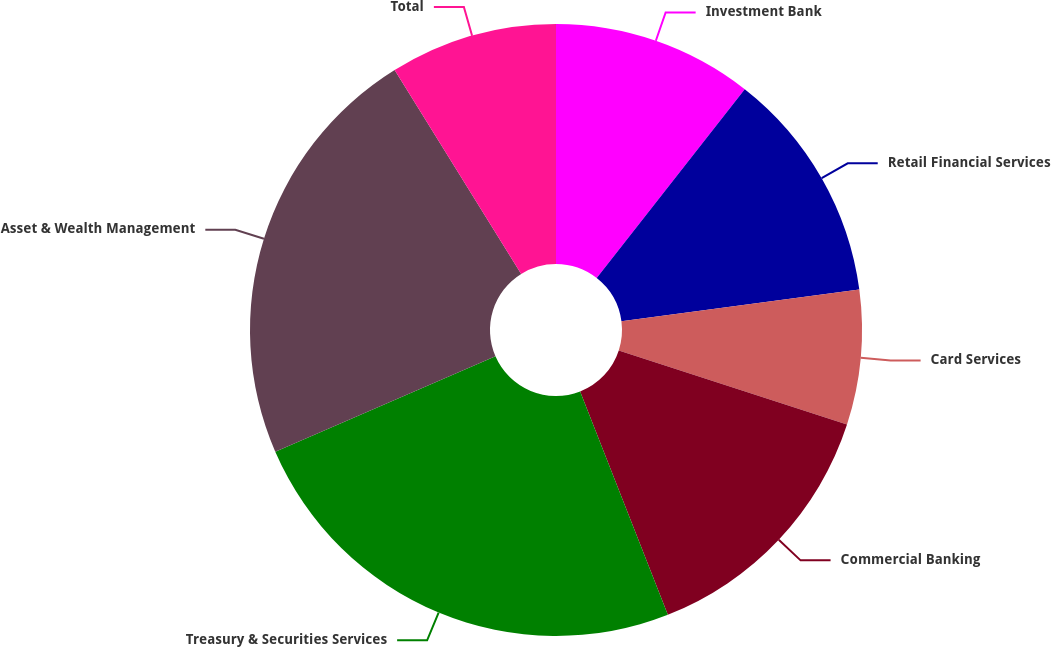<chart> <loc_0><loc_0><loc_500><loc_500><pie_chart><fcel>Investment Bank<fcel>Retail Financial Services<fcel>Card Services<fcel>Commercial Banking<fcel>Treasury & Securities Services<fcel>Asset & Wealth Management<fcel>Total<nl><fcel>10.58%<fcel>12.31%<fcel>7.11%<fcel>14.04%<fcel>24.44%<fcel>22.67%<fcel>8.84%<nl></chart> 